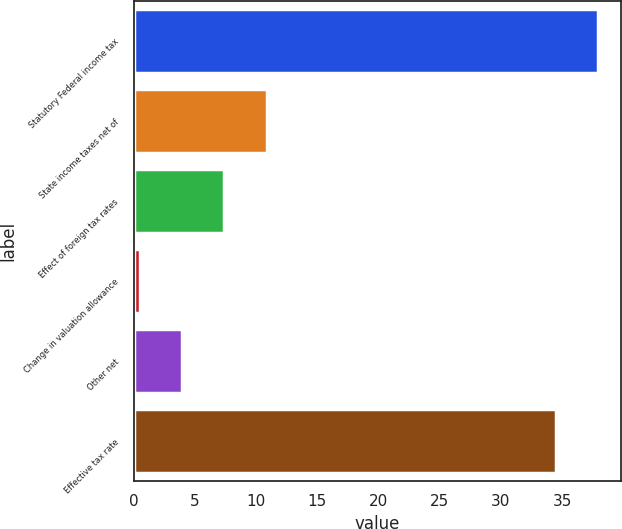Convert chart to OTSL. <chart><loc_0><loc_0><loc_500><loc_500><bar_chart><fcel>Statutory Federal income tax<fcel>State income taxes net of<fcel>Effect of foreign tax rates<fcel>Change in valuation allowance<fcel>Other net<fcel>Effective tax rate<nl><fcel>37.95<fcel>10.85<fcel>7.4<fcel>0.5<fcel>3.95<fcel>34.5<nl></chart> 